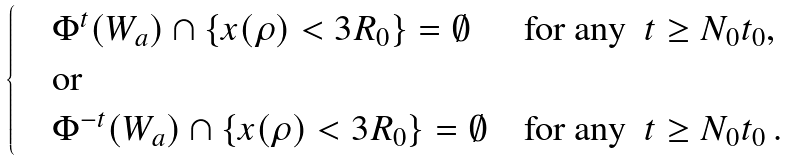Convert formula to latex. <formula><loc_0><loc_0><loc_500><loc_500>\begin{cases} \quad \Phi ^ { t } ( W _ { a } ) \cap \{ x ( \rho ) < 3 R _ { 0 } \} = \emptyset & \text {for any } \ t \geq N _ { 0 } t _ { 0 } , \\ \quad \text {or} \\ \quad \Phi ^ { - t } ( W _ { a } ) \cap \{ x ( \rho ) < 3 R _ { 0 } \} = \emptyset & \text {for any } \ t \geq N _ { 0 } t _ { 0 } \, . \end{cases}</formula> 